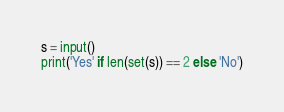<code> <loc_0><loc_0><loc_500><loc_500><_Python_>s = input()
print('Yes' if len(set(s)) == 2 else 'No')
</code> 